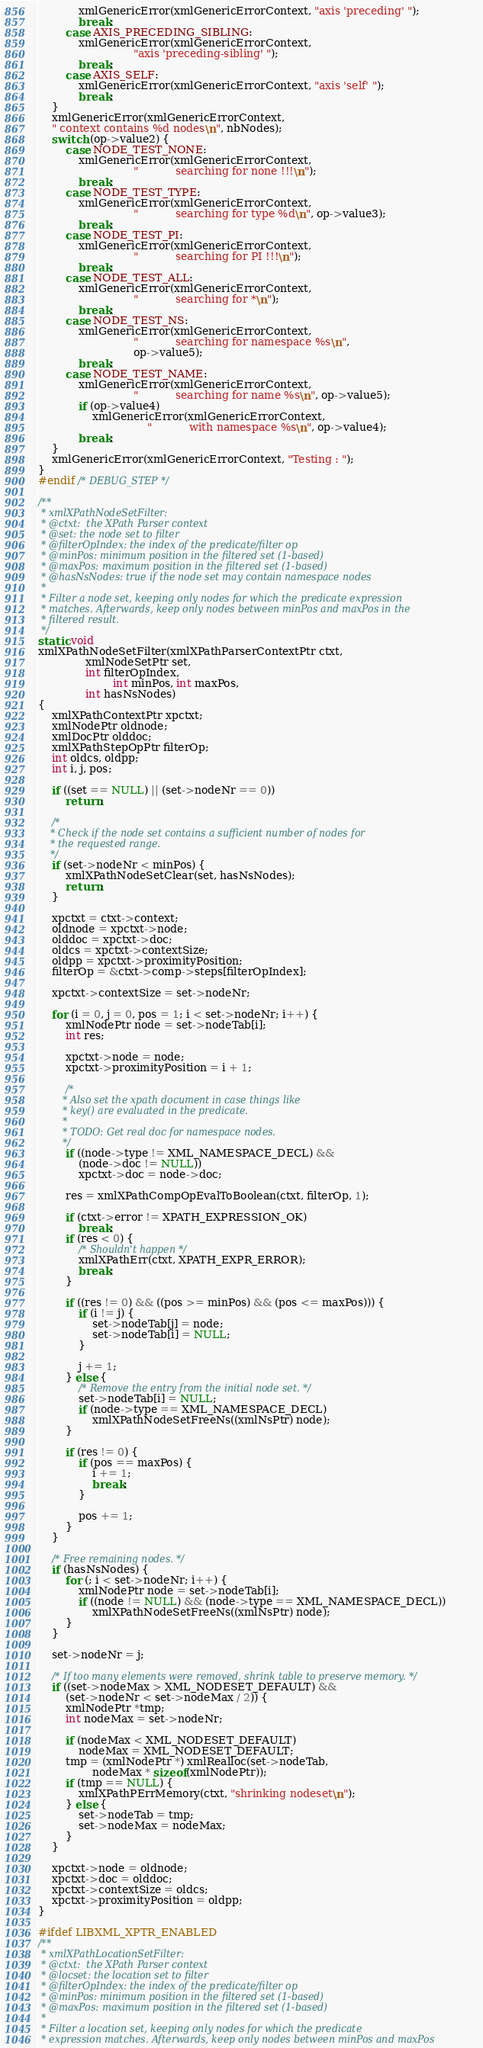<code> <loc_0><loc_0><loc_500><loc_500><_C_>            xmlGenericError(xmlGenericErrorContext, "axis 'preceding' ");
            break;
        case AXIS_PRECEDING_SIBLING:
            xmlGenericError(xmlGenericErrorContext,
                            "axis 'preceding-sibling' ");
            break;
        case AXIS_SELF:
            xmlGenericError(xmlGenericErrorContext, "axis 'self' ");
            break;
    }
    xmlGenericError(xmlGenericErrorContext,
	" context contains %d nodes\n", nbNodes);
    switch (op->value2) {
        case NODE_TEST_NONE:
            xmlGenericError(xmlGenericErrorContext,
                            "           searching for none !!!\n");
            break;
        case NODE_TEST_TYPE:
            xmlGenericError(xmlGenericErrorContext,
                            "           searching for type %d\n", op->value3);
            break;
        case NODE_TEST_PI:
            xmlGenericError(xmlGenericErrorContext,
                            "           searching for PI !!!\n");
            break;
        case NODE_TEST_ALL:
            xmlGenericError(xmlGenericErrorContext,
                            "           searching for *\n");
            break;
        case NODE_TEST_NS:
            xmlGenericError(xmlGenericErrorContext,
                            "           searching for namespace %s\n",
                            op->value5);
            break;
        case NODE_TEST_NAME:
            xmlGenericError(xmlGenericErrorContext,
                            "           searching for name %s\n", op->value5);
            if (op->value4)
                xmlGenericError(xmlGenericErrorContext,
                                "           with namespace %s\n", op->value4);
            break;
    }
    xmlGenericError(xmlGenericErrorContext, "Testing : ");
}
#endif /* DEBUG_STEP */

/**
 * xmlXPathNodeSetFilter:
 * @ctxt:  the XPath Parser context
 * @set: the node set to filter
 * @filterOpIndex: the index of the predicate/filter op
 * @minPos: minimum position in the filtered set (1-based)
 * @maxPos: maximum position in the filtered set (1-based)
 * @hasNsNodes: true if the node set may contain namespace nodes
 *
 * Filter a node set, keeping only nodes for which the predicate expression
 * matches. Afterwards, keep only nodes between minPos and maxPos in the
 * filtered result.
 */
static void
xmlXPathNodeSetFilter(xmlXPathParserContextPtr ctxt,
		      xmlNodeSetPtr set,
		      int filterOpIndex,
                      int minPos, int maxPos,
		      int hasNsNodes)
{
    xmlXPathContextPtr xpctxt;
    xmlNodePtr oldnode;
    xmlDocPtr olddoc;
    xmlXPathStepOpPtr filterOp;
    int oldcs, oldpp;
    int i, j, pos;

    if ((set == NULL) || (set->nodeNr == 0))
        return;

    /*
    * Check if the node set contains a sufficient number of nodes for
    * the requested range.
    */
    if (set->nodeNr < minPos) {
        xmlXPathNodeSetClear(set, hasNsNodes);
        return;
    }

    xpctxt = ctxt->context;
    oldnode = xpctxt->node;
    olddoc = xpctxt->doc;
    oldcs = xpctxt->contextSize;
    oldpp = xpctxt->proximityPosition;
    filterOp = &ctxt->comp->steps[filterOpIndex];

    xpctxt->contextSize = set->nodeNr;

    for (i = 0, j = 0, pos = 1; i < set->nodeNr; i++) {
        xmlNodePtr node = set->nodeTab[i];
        int res;

        xpctxt->node = node;
        xpctxt->proximityPosition = i + 1;

        /*
        * Also set the xpath document in case things like
        * key() are evaluated in the predicate.
        *
        * TODO: Get real doc for namespace nodes.
        */
        if ((node->type != XML_NAMESPACE_DECL) &&
            (node->doc != NULL))
            xpctxt->doc = node->doc;

        res = xmlXPathCompOpEvalToBoolean(ctxt, filterOp, 1);

        if (ctxt->error != XPATH_EXPRESSION_OK)
            break;
        if (res < 0) {
            /* Shouldn't happen */
            xmlXPathErr(ctxt, XPATH_EXPR_ERROR);
            break;
        }

        if ((res != 0) && ((pos >= minPos) && (pos <= maxPos))) {
            if (i != j) {
                set->nodeTab[j] = node;
                set->nodeTab[i] = NULL;
            }

            j += 1;
        } else {
            /* Remove the entry from the initial node set. */
            set->nodeTab[i] = NULL;
            if (node->type == XML_NAMESPACE_DECL)
                xmlXPathNodeSetFreeNs((xmlNsPtr) node);
        }

        if (res != 0) {
            if (pos == maxPos) {
                i += 1;
                break;
            }

            pos += 1;
        }
    }

    /* Free remaining nodes. */
    if (hasNsNodes) {
        for (; i < set->nodeNr; i++) {
            xmlNodePtr node = set->nodeTab[i];
            if ((node != NULL) && (node->type == XML_NAMESPACE_DECL))
                xmlXPathNodeSetFreeNs((xmlNsPtr) node);
        }
    }

    set->nodeNr = j;

    /* If too many elements were removed, shrink table to preserve memory. */
    if ((set->nodeMax > XML_NODESET_DEFAULT) &&
        (set->nodeNr < set->nodeMax / 2)) {
        xmlNodePtr *tmp;
        int nodeMax = set->nodeNr;

        if (nodeMax < XML_NODESET_DEFAULT)
            nodeMax = XML_NODESET_DEFAULT;
        tmp = (xmlNodePtr *) xmlRealloc(set->nodeTab,
                nodeMax * sizeof(xmlNodePtr));
        if (tmp == NULL) {
            xmlXPathPErrMemory(ctxt, "shrinking nodeset\n");
        } else {
            set->nodeTab = tmp;
            set->nodeMax = nodeMax;
        }
    }

    xpctxt->node = oldnode;
    xpctxt->doc = olddoc;
    xpctxt->contextSize = oldcs;
    xpctxt->proximityPosition = oldpp;
}

#ifdef LIBXML_XPTR_ENABLED
/**
 * xmlXPathLocationSetFilter:
 * @ctxt:  the XPath Parser context
 * @locset: the location set to filter
 * @filterOpIndex: the index of the predicate/filter op
 * @minPos: minimum position in the filtered set (1-based)
 * @maxPos: maximum position in the filtered set (1-based)
 *
 * Filter a location set, keeping only nodes for which the predicate
 * expression matches. Afterwards, keep only nodes between minPos and maxPos</code> 